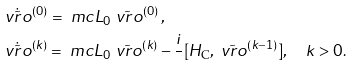Convert formula to latex. <formula><loc_0><loc_0><loc_500><loc_500>& \dot { \tilde { \ v r o } } ^ { ( 0 ) } = \ m c { L } _ { 0 } \tilde { \ v r o } ^ { ( 0 ) } \, , \\ & \dot { \tilde { \ v r o } } ^ { ( k ) } = \ m c { L } _ { 0 } \tilde { \ v r o } ^ { ( k ) } - \frac { i } { } [ H _ { \text {C} } , \tilde { \ v r o } ^ { ( k - 1 ) } ] , \quad k > 0 .</formula> 